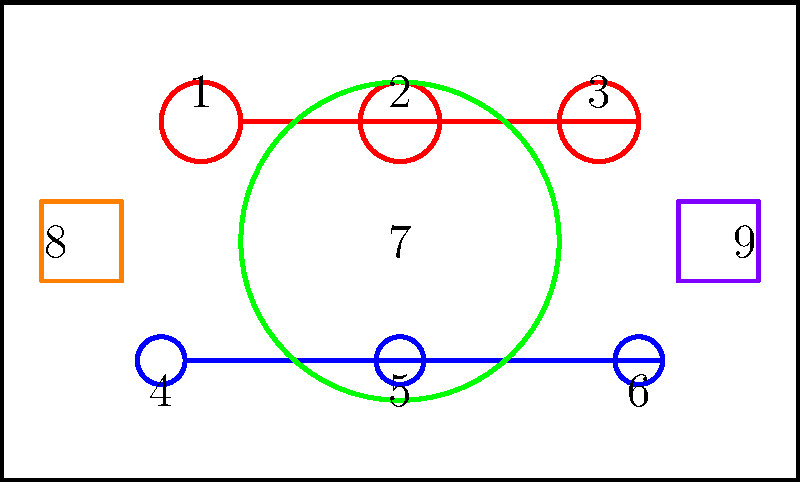As a metal music enthusiast, you're tasked with assembling a classic tube amplifier. Given the diagram of disassembled parts, determine the correct order of assembly to ensure optimal sound quality and performance. Which of the following sequences represents the proper assembly order?

A) 8, 9, 7, 1, 2, 3, 4, 5, 6
B) 7, 1, 2, 3, 8, 9, 4, 5, 6
C) 1, 2, 3, 4, 5, 6, 7, 8, 9
D) 8, 9, 4, 5, 6, 7, 1, 2, 3 To assemble a tube amplifier correctly, we need to follow a logical sequence that ensures proper functionality and safety. Let's break down the assembly process step-by-step:

1. Start with the chassis (not numbered, but represented by the outer box).
2. Install the input (8) and output (9) jacks. These are fundamental for signal flow and should be installed early.
3. Mount the power transformer (not shown in the diagram but assumed to be part of the initial chassis setup).
4. Install the filter capacitors (also not shown but crucial for power supply).
5. Mount the tube sockets (where 1, 2, and 3 will be inserted).
6. Install the potentiometers or variable resistors (where 4, 5, and 6 will be attached).
7. Mount the speaker (7). This is typically one of the last major components to be installed.
8. Insert the tubes (1, 2, and 3) into their sockets.
9. Attach the control knobs (4, 5, and 6) to the potentiometers.

This sequence ensures that the internal components are installed before the more delicate or adjustable parts. It also allows for easier access during the build process.

Based on this logical assembly order, the correct sequence is:

B) 7, 1, 2, 3, 8, 9, 4, 5, 6

This sequence closely follows our step-by-step process, with the speaker (7) mounted first (as it's a major component), followed by the tubes (1, 2, 3), then the input/output jacks (8, 9), and finally the control knobs (4, 5, 6).
Answer: B) 7, 1, 2, 3, 8, 9, 4, 5, 6 